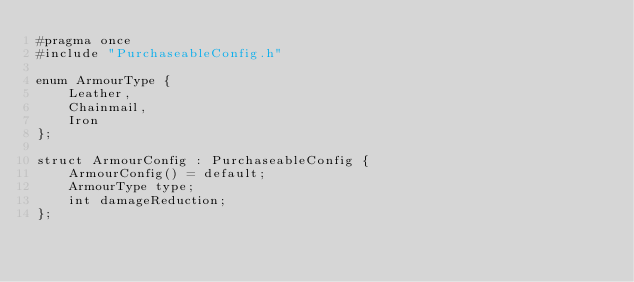<code> <loc_0><loc_0><loc_500><loc_500><_C_>#pragma once 
#include "PurchaseableConfig.h"

enum ArmourType {
	Leather,
	Chainmail,
	Iron
};

struct ArmourConfig : PurchaseableConfig {
	ArmourConfig() = default;
	ArmourType type;
	int damageReduction;
};</code> 